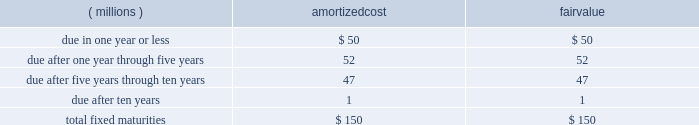Notes to consolidated financial statements the amortized cost and fair value of fixed maturities by contractual maturity as of december 31 , 2007 , are as follows : amortized fair ( millions ) cost value .
Expected maturities may differ from contractual maturities because borrowers may have the right to call or prepay obligations with or without call or prepayment penalties .
For categorization purposes , aon considers any rating of baa or higher by moody 2019s investor services or equivalent rating agency to be investment grade .
Aon 2019s continuing operations have no fixed maturities with an unrealized loss at december 31 , 2007 .
Aon 2019s fixed-maturity portfolio is subject to interest rate , market and credit risks .
With a carrying value of approximately $ 150 million at december 31 , 2007 , aon 2019s total fixed-maturity portfolio is approximately 96% ( 96 % ) investment grade based on market value .
Aon 2019s non publicly-traded fixed maturity portfolio had a carrying value of $ 9 million .
Valuations of these securities primarily reflect the fundamental analysis of the issuer and current market price of comparable securities .
Aon 2019s equity portfolio is comprised of a preferred stock not publicly traded .
This portfolio is subject to interest rate , market , credit , illiquidity , concentration and operational performance risks .
Limited partnership securitization .
In 2001 , aon sold the vast majority of its limited partnership ( lp ) portfolio , valued at $ 450 million , to peps i , a qspe .
The common stock interest in peps i is held by a limited liability company which is owned by aon ( 49% ( 49 % ) ) and by a charitable trust , which is not controlled by aon , established for victims of september 11 ( 51% ( 51 % ) ) .
Approximately $ 171 million of investment grade fixed-maturity securities were sold by peps i to unaffiliated third parties .
Peps i then paid aon 2019s insurance underwriting subsidiaries the $ 171 million in cash and issued to them an additional $ 279 million in fixed-maturity and preferred stock securities .
As part of this transaction , aon is required to purchase from peps i additional fixed-maturity securities in an amount equal to the unfunded limited partnership commitments , as they are requested .
Aon funded $ 2 million of commitments in both 2007 and 2006 .
As of december 31 , 2007 , these unfunded commitments amounted to $ 44 million .
These commitments have specific expiration dates and the general partners may decide not to draw on these commitments .
The carrying value of the peps i preferred stock was $ 168 million and $ 210 million at december 31 , 2007 and 2006 , respectively .
Prior to 2007 , income distributions received from peps i were limited to interest payments on various peps i debt instruments .
Beginning in 2007 , peps i had redeemed or collateralized all of its debt , and as a result , began to pay preferred income distributions .
In 2007 , the company received $ 61 million of income distributions from peps i , which are included in investment income .
Aon corporation .
After selling the its lp portfolio to peps i , what is the value of lp is still owned by aon indirectly , ( in millions ) ? 
Computations: (49% - 450)
Answer: -449.51. 